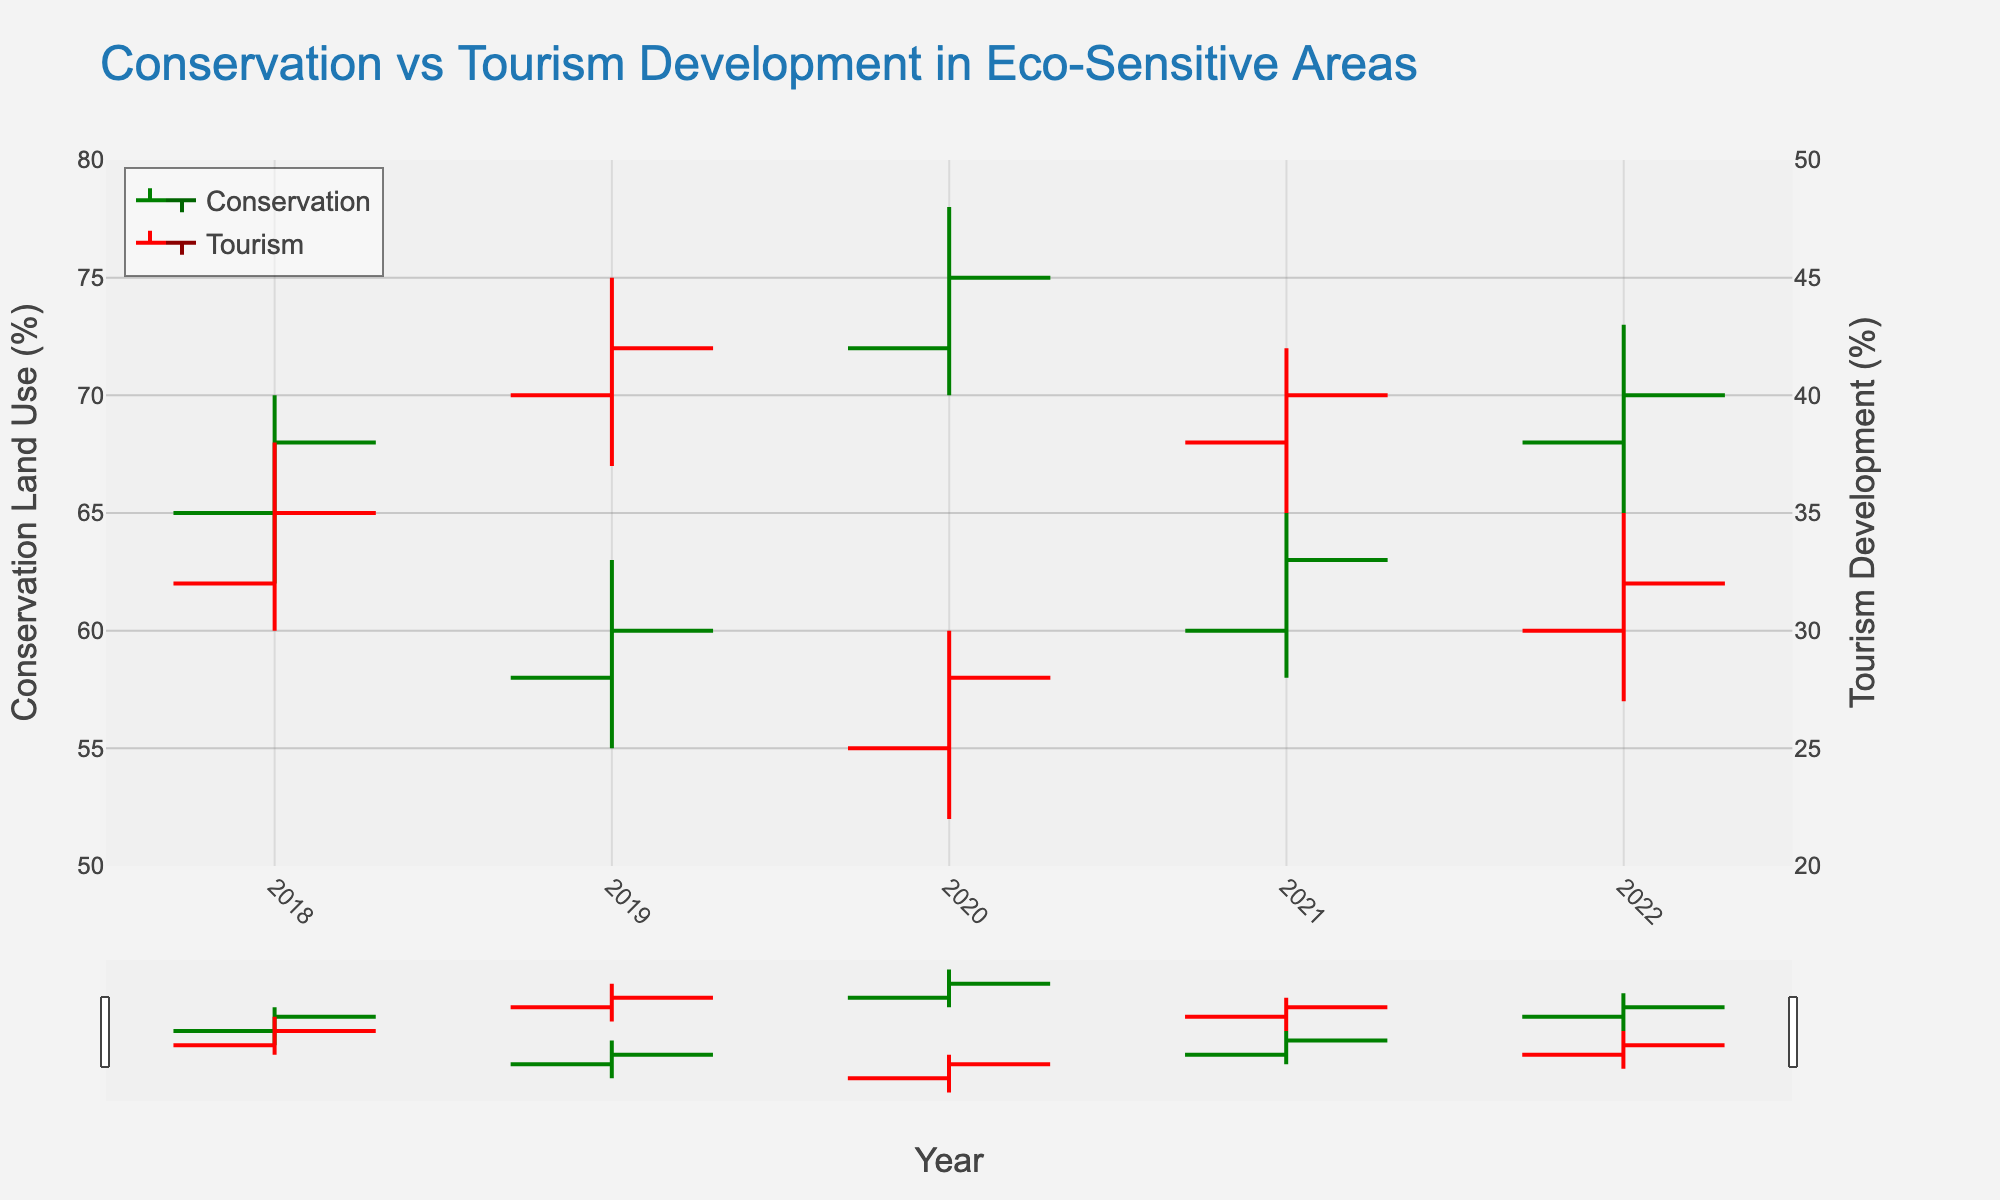What is the title of the plot? The title of the plot is displayed at the top of the visualization.
Answer: Conservation vs Tourism Development in Eco-Sensitive Areas How many locations are covered in the figure? The data covers a span of 5 years (2018-2022), with each year representing a different location for analysis.
Answer: 5 Which year showed the highest conservation close value? To determine this, observe the conservation close values for each year. The highest close value is in 2020 for the Great Barrier Reef.
Answer: 75 What is the trend for tourism development from 2018 to 2022? Examine the tourism development open and close values across the years. There's a general increasing trend of tourism development from 32 (Open) in 2018 to 35 (Close) in 2022.
Answer: Increasing In which year was the gap between conservation high and low values the largest? Calculate the difference between conservation high and low values for each year. The largest gap is in 2020 for the Great Barrier Reef (78-70=8).
Answer: 2020 What is the average conservation close value across the five locations? Add the conservation close values of each year: 68+60+75+63+70 = 336, then divide by the number of locations (5).
Answer: 67.2 How does the conservation high value in 2021 compare to the tourism high value in the same year? Compare the conservation high value (65) and tourism high value (42) for 2021. The conservation high value is greater.
Answer: Conservation high is greater What is the lowest tourism open value depicted in the chart and in which year? Check the tourism open values for all years and find the lowest, which is 25 in 2020 for the Great Barrier Reef.
Answer: 25 in 2020 Between 2020 and 2021, how did the conservation close values change? Compare the conservation close values for 2020 (75) and 2021 (63). The value decreased by 12 units.
Answer: Decreased by 12 Identify a year when conservation efforts and tourism development both had their respective highest values. Find the year where both conservation high and tourism high values are at their peaks. This is in 2020 for the Great Barrier Reef (Conservation High: 78, Tourism High: 30).
Answer: 2020 